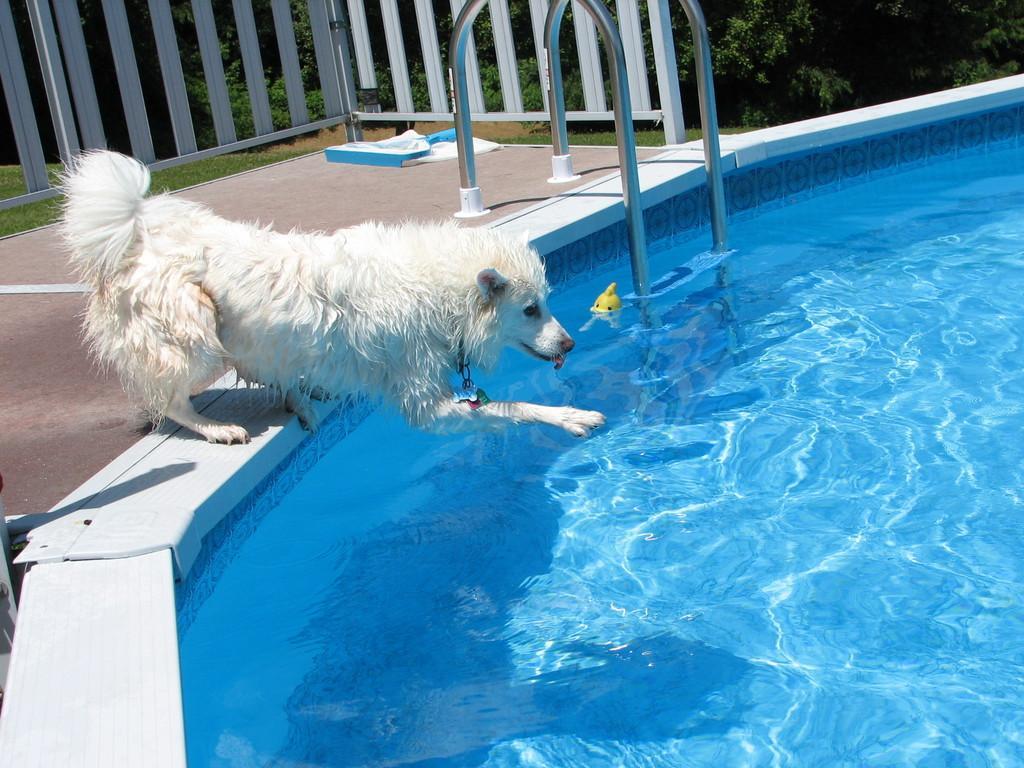Could you give a brief overview of what you see in this image? In this image I can see the dog and the dog is in white color and I can also see the water. Background I can see the railing and I can also see few plants in green color. 